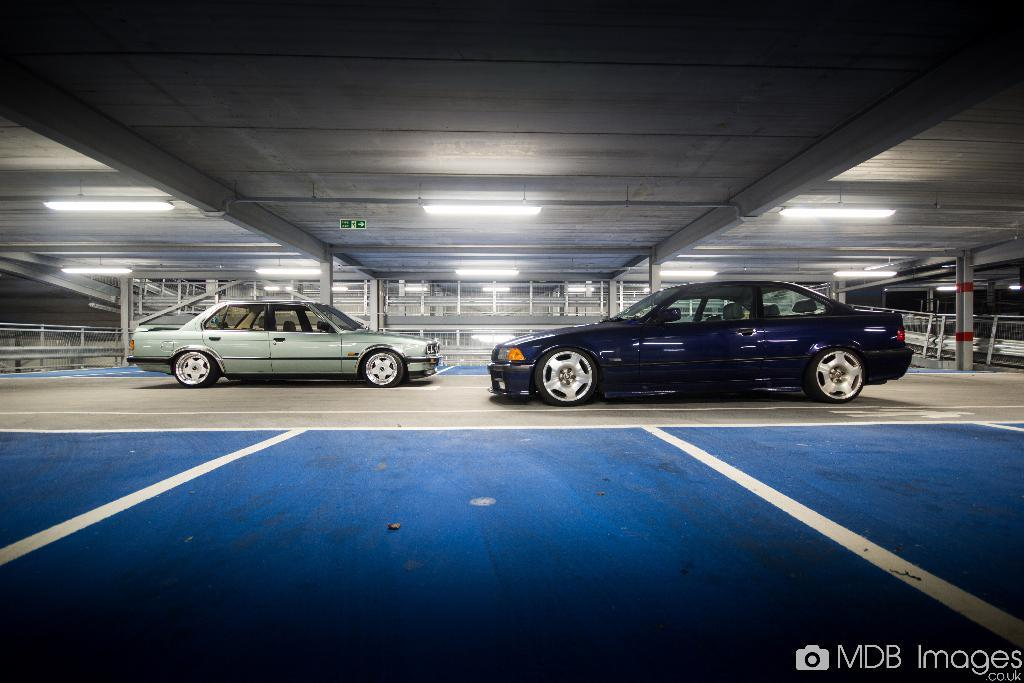How many cars are inside the shed in the image? There are two cars inside the shed in the image. What can be seen on the ceiling of the shed? There are many lights in the top of the shed. What is the color of the road outside the shed? The road outside the shed has a blue and ash color. What note is written on the windshield of the car in the image? There is no note written on the windshield of the car in the image. What route is the car taking in the image? The image does not show the car in motion, so it is not possible to determine the route it is taking. 